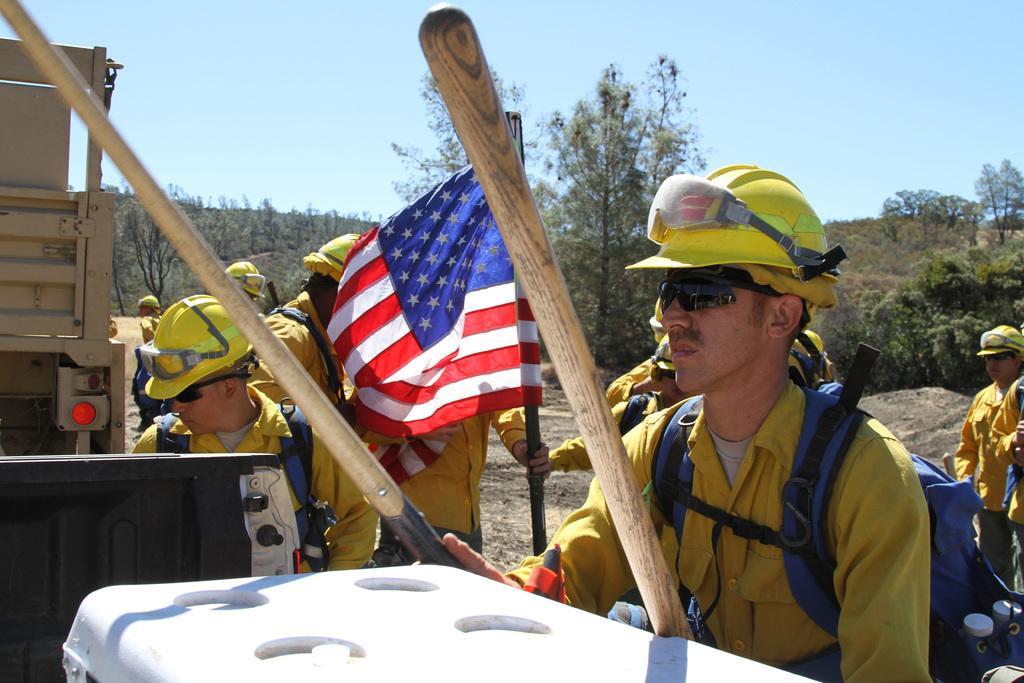In one or two sentences, can you explain what this image depicts? In this image we can see few people standing on the ground, a person is holding a flag and a person is holding a wooden stick and wearing a backpack, there is a white color object in front of the person and an object looks like a vehicle and there are few trees and the sky in the background. 